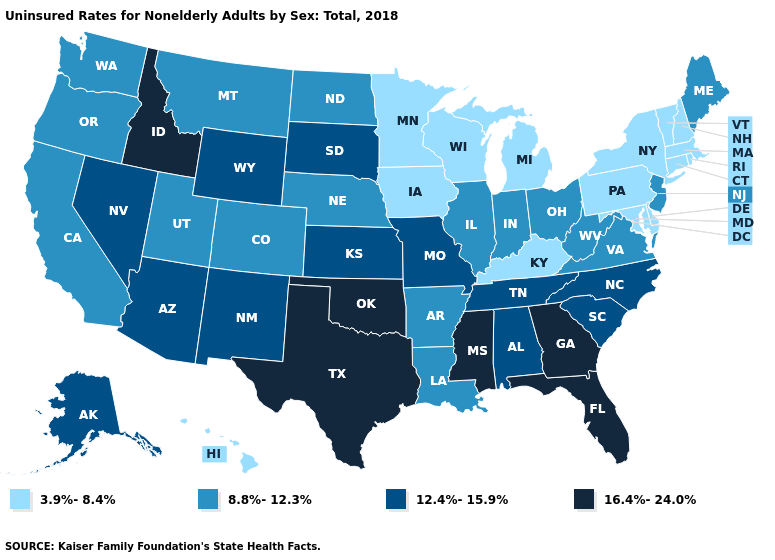Does the map have missing data?
Be succinct. No. What is the highest value in the USA?
Quick response, please. 16.4%-24.0%. What is the lowest value in the South?
Give a very brief answer. 3.9%-8.4%. Does Maine have a lower value than West Virginia?
Give a very brief answer. No. Does Maine have a lower value than Georgia?
Be succinct. Yes. What is the lowest value in the West?
Keep it brief. 3.9%-8.4%. Does Maine have the same value as Florida?
Concise answer only. No. What is the highest value in the South ?
Short answer required. 16.4%-24.0%. Does Hawaii have the lowest value in the West?
Answer briefly. Yes. Does Hawaii have the highest value in the USA?
Keep it brief. No. What is the lowest value in the South?
Concise answer only. 3.9%-8.4%. Which states have the lowest value in the USA?
Answer briefly. Connecticut, Delaware, Hawaii, Iowa, Kentucky, Maryland, Massachusetts, Michigan, Minnesota, New Hampshire, New York, Pennsylvania, Rhode Island, Vermont, Wisconsin. What is the value of Utah?
Answer briefly. 8.8%-12.3%. What is the value of Maine?
Keep it brief. 8.8%-12.3%. Is the legend a continuous bar?
Answer briefly. No. 